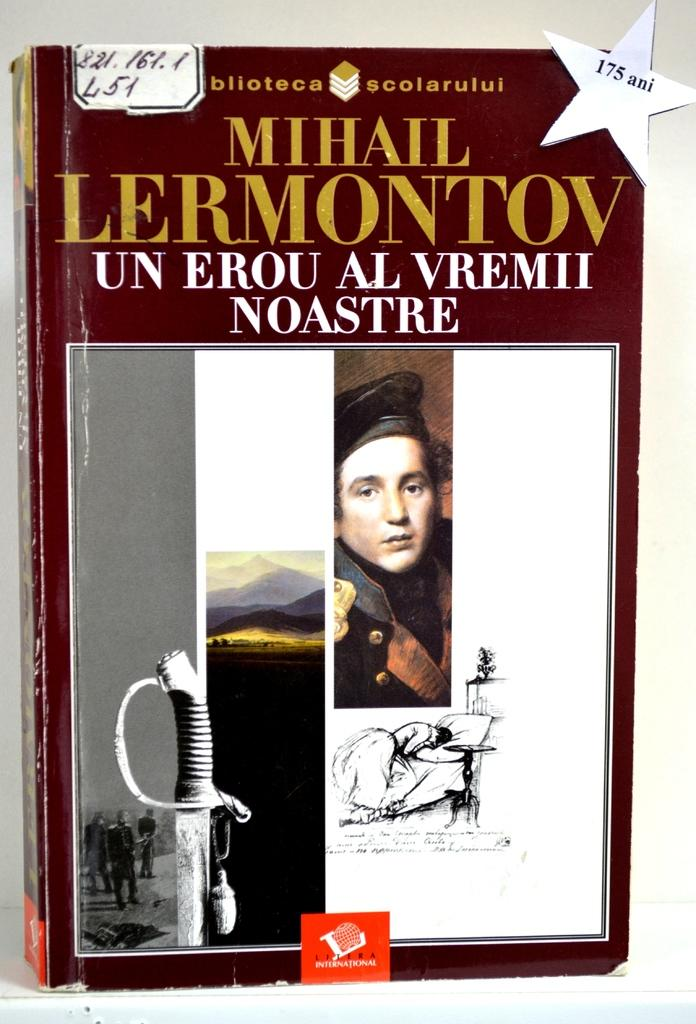<image>
Share a concise interpretation of the image provided. Book cover titled "Mihail Lermontov" showing a soldier's face and a sword. 